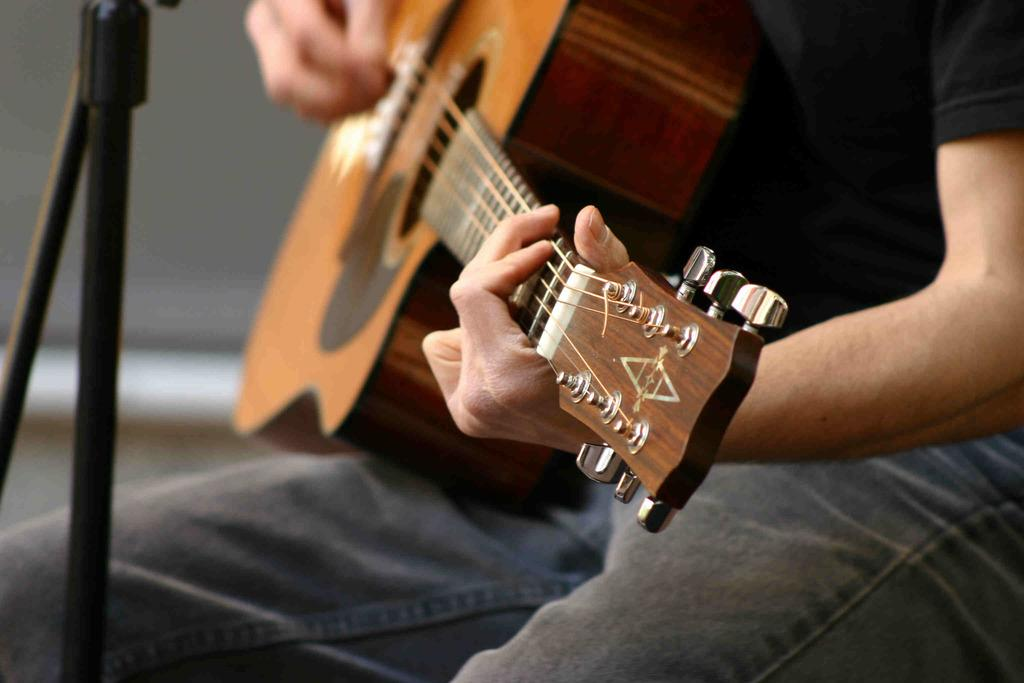What is the main subject of the image? The main subject of the image is a man. What is the man doing in the image? The man is sitting in the image. What object is the man holding in his hand? The man is holding a guitar in his hand. What is in front of the man? There is a stand in front of the man. What type of loaf is the man working on in the office? There is no loaf or office present in the image; it features a man sitting and holding a guitar. 